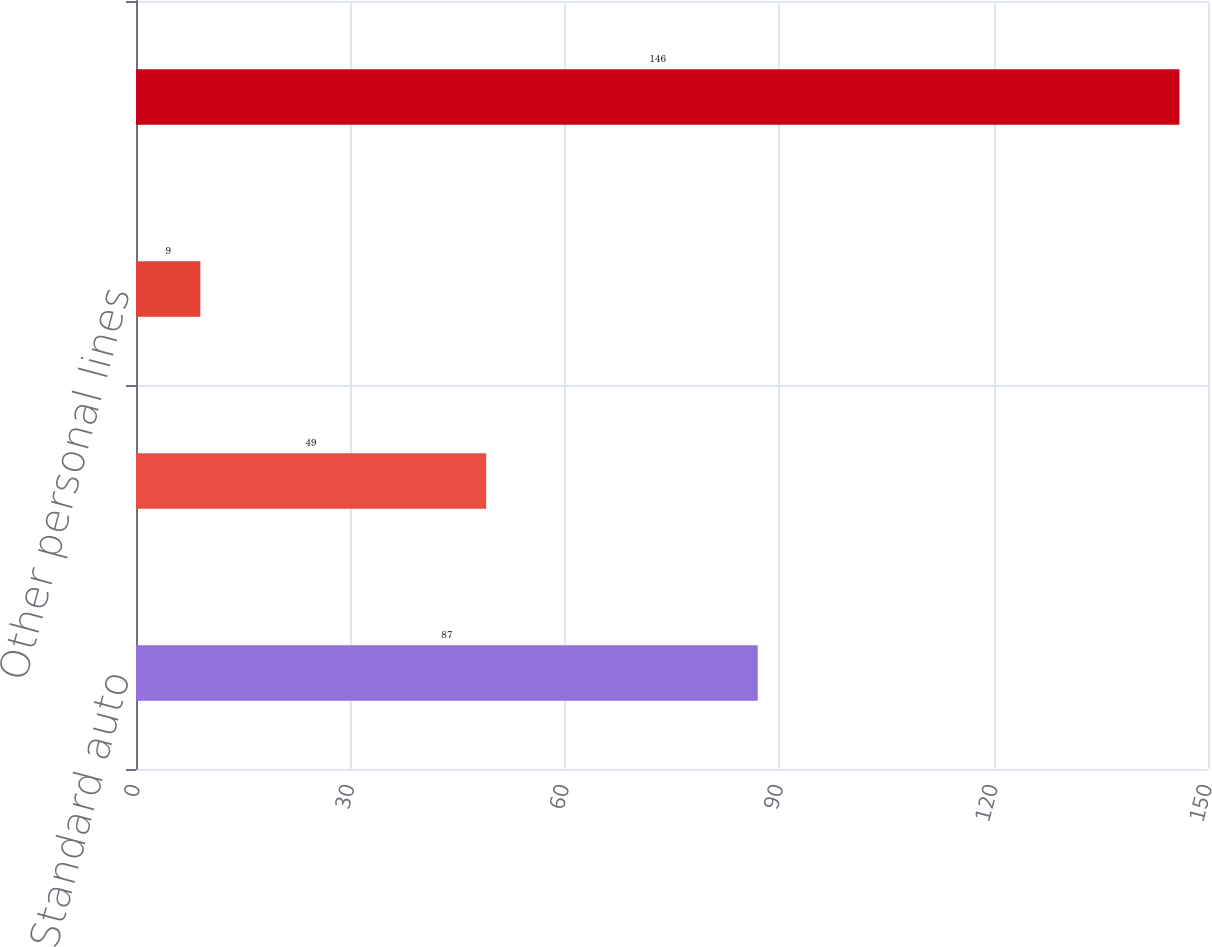Convert chart to OTSL. <chart><loc_0><loc_0><loc_500><loc_500><bar_chart><fcel>Standard auto<fcel>Homeowners<fcel>Other personal lines<fcel>Total DAC<nl><fcel>87<fcel>49<fcel>9<fcel>146<nl></chart> 